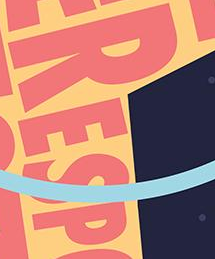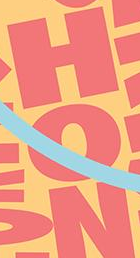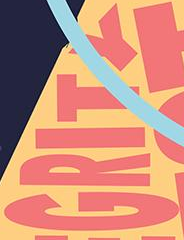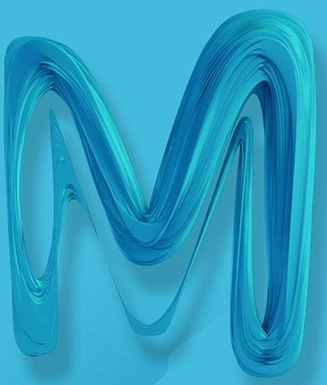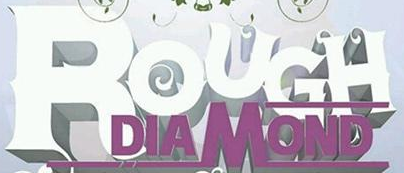What text appears in these images from left to right, separated by a semicolon? RESP; HON; GRITY; M; ROUGH 